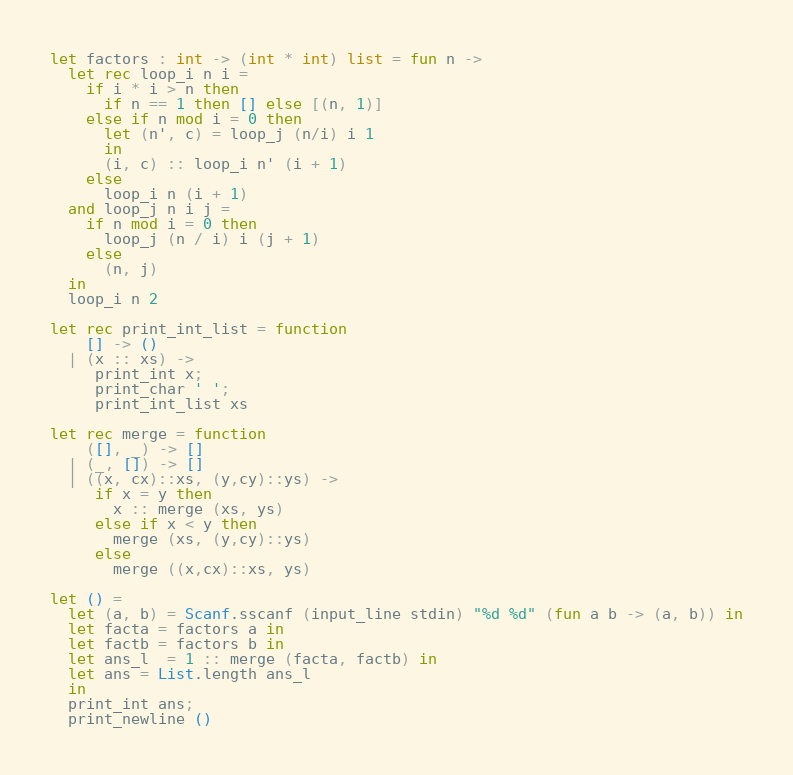Convert code to text. <code><loc_0><loc_0><loc_500><loc_500><_OCaml_>let factors : int -> (int * int) list = fun n ->
  let rec loop_i n i =
    if i * i > n then
      if n == 1 then [] else [(n, 1)]
    else if n mod i = 0 then
      let (n', c) = loop_j (n/i) i 1
      in
      (i, c) :: loop_i n' (i + 1)
    else
      loop_i n (i + 1)
  and loop_j n i j =
    if n mod i = 0 then
      loop_j (n / i) i (j + 1)
    else
      (n, j)
  in
  loop_i n 2

let rec print_int_list = function
    [] -> ()
  | (x :: xs) ->
     print_int x;
     print_char ' ';
     print_int_list xs

let rec merge = function
    ([], _) -> []
  | (_, []) -> []
  | ((x, cx)::xs, (y,cy)::ys) ->
     if x = y then
       x :: merge (xs, ys)
     else if x < y then
       merge (xs, (y,cy)::ys)
     else
       merge ((x,cx)::xs, ys)

let () =
  let (a, b) = Scanf.sscanf (input_line stdin) "%d %d" (fun a b -> (a, b)) in
  let facta = factors a in
  let factb = factors b in
  let ans_l  = 1 :: merge (facta, factb) in
  let ans = List.length ans_l
  in
  print_int ans;
  print_newline ()
</code> 